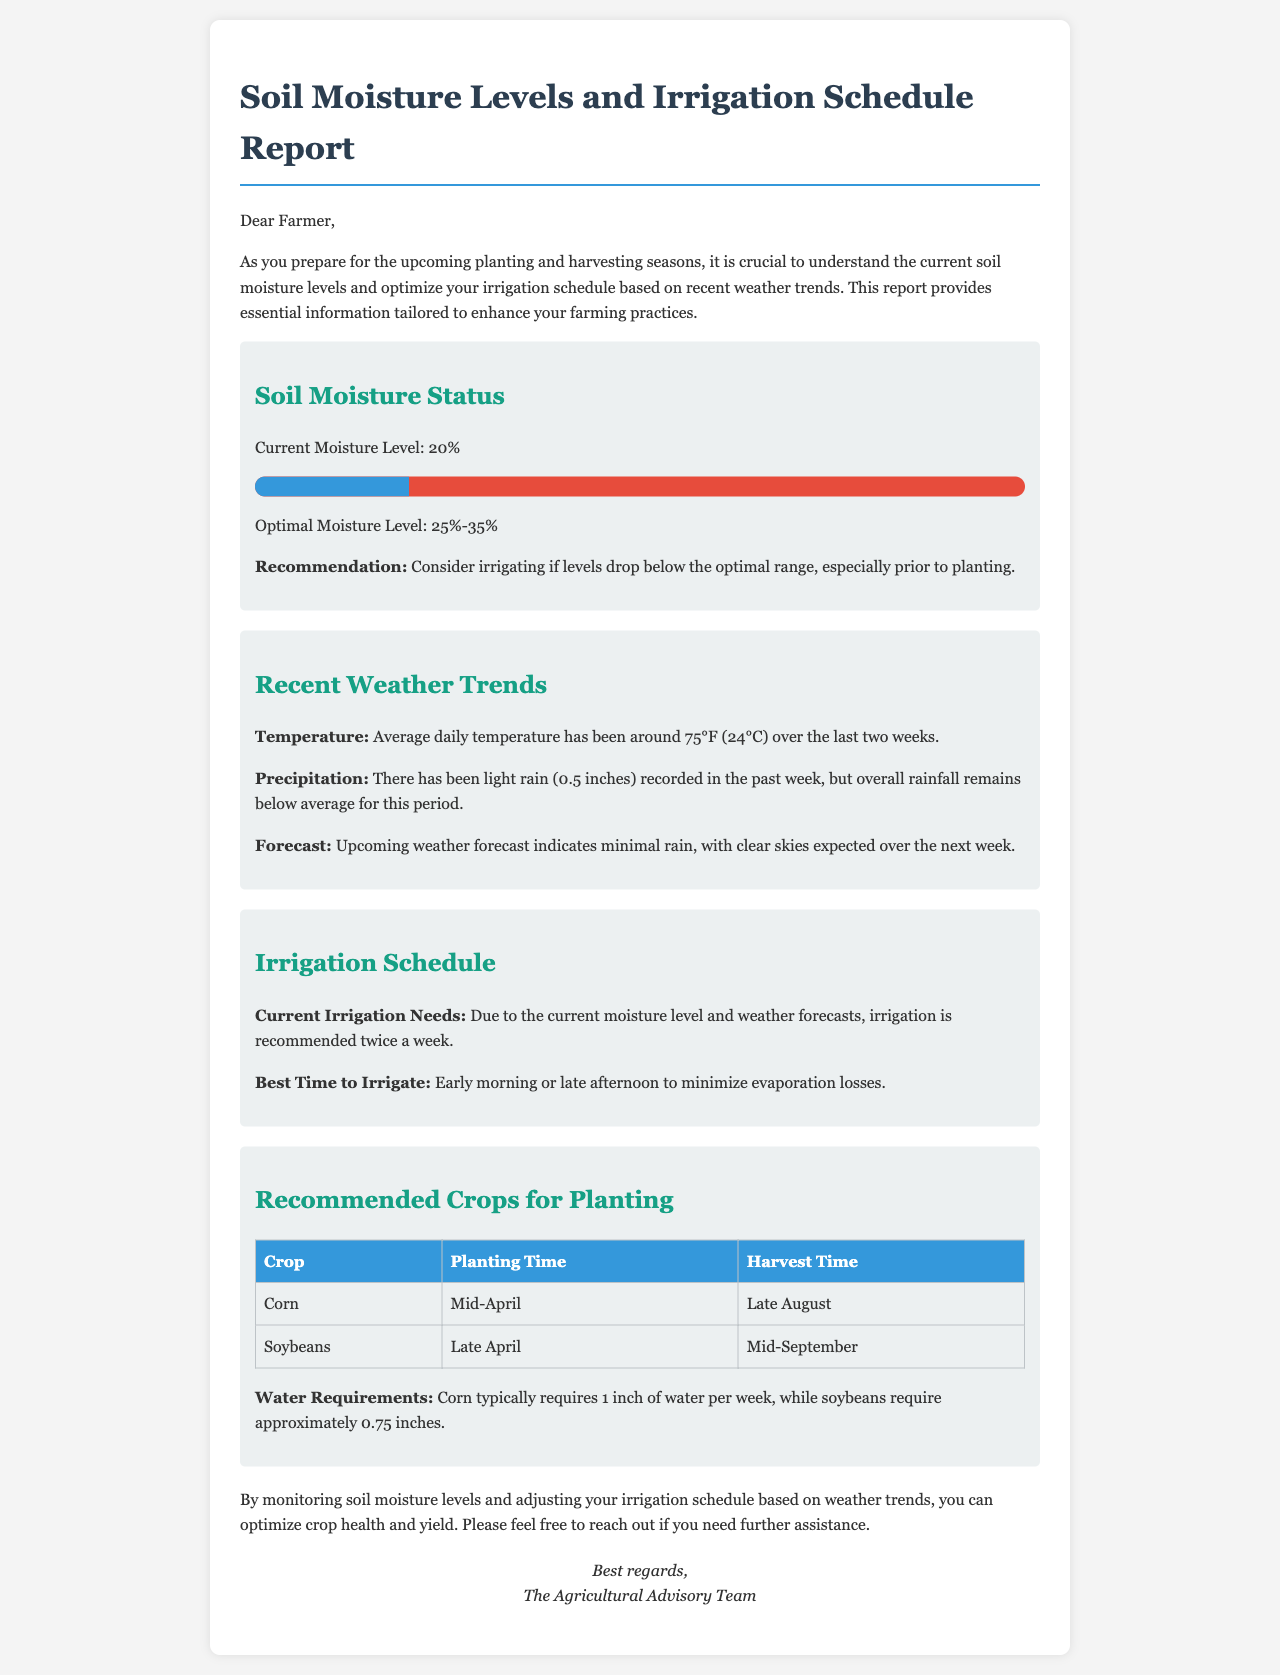What is the current moisture level? The current moisture level is stated in the report as 20%.
Answer: 20% What is the optimal moisture level range? The report specifies the optimal moisture level range as 25%-35%.
Answer: 25%-35% How often is irrigation recommended? The irrigation schedule advises that irrigation is needed twice a week based on current moisture and forecasts.
Answer: Twice a week What was the total rainfall in the past week? The report mentions a light rain of 0.5 inches recorded in the past week.
Answer: 0.5 inches What is the best time to irrigate? The report states that the best time to irrigate is early morning or late afternoon.
Answer: Early morning or late afternoon When is corn planting time? The report indicates that corn should be planted in mid-April.
Answer: Mid-April Which crop requires 0.75 inches of water per week? The document specifies that soybeans require approximately 0.75 inches of water per week.
Answer: Soybeans What does the report recommend if moisture levels drop below the optimal range? The recommendation is to consider irrigating if levels fall below the optimal range, particularly before planting.
Answer: Consider irrigating What is the average daily temperature over the last two weeks? The document states that the average daily temperature has been around 75°F (24°C) for the past two weeks.
Answer: 75°F (24°C) 